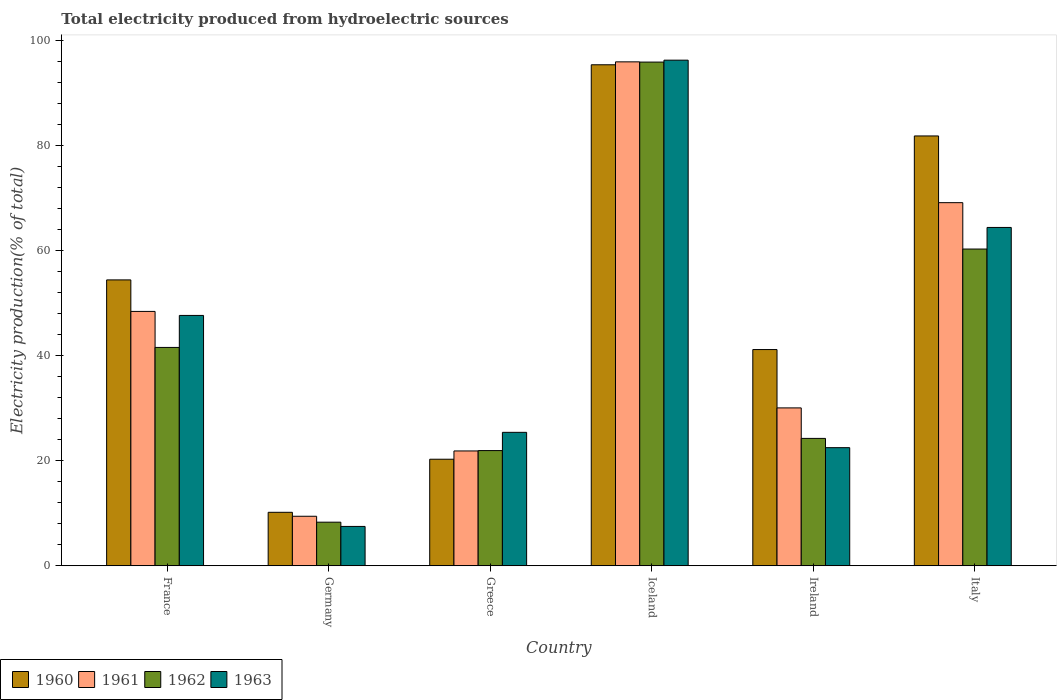How many different coloured bars are there?
Your response must be concise. 4. How many bars are there on the 2nd tick from the left?
Your answer should be compact. 4. How many bars are there on the 3rd tick from the right?
Offer a terse response. 4. What is the label of the 4th group of bars from the left?
Give a very brief answer. Iceland. In how many cases, is the number of bars for a given country not equal to the number of legend labels?
Your answer should be very brief. 0. What is the total electricity produced in 1963 in France?
Your answer should be compact. 47.7. Across all countries, what is the maximum total electricity produced in 1963?
Offer a very short reply. 96.34. Across all countries, what is the minimum total electricity produced in 1962?
Provide a short and direct response. 8.31. What is the total total electricity produced in 1963 in the graph?
Your answer should be compact. 263.95. What is the difference between the total electricity produced in 1963 in Iceland and that in Ireland?
Provide a succinct answer. 73.83. What is the difference between the total electricity produced in 1960 in Iceland and the total electricity produced in 1963 in Greece?
Keep it short and to the point. 70.03. What is the average total electricity produced in 1962 per country?
Your response must be concise. 42.08. What is the difference between the total electricity produced of/in 1963 and total electricity produced of/in 1961 in Ireland?
Provide a succinct answer. -7.58. What is the ratio of the total electricity produced in 1961 in Greece to that in Iceland?
Provide a short and direct response. 0.23. Is the total electricity produced in 1963 in Greece less than that in Iceland?
Provide a succinct answer. Yes. What is the difference between the highest and the second highest total electricity produced in 1960?
Give a very brief answer. 27.43. What is the difference between the highest and the lowest total electricity produced in 1962?
Your answer should be very brief. 87.67. In how many countries, is the total electricity produced in 1960 greater than the average total electricity produced in 1960 taken over all countries?
Make the answer very short. 3. Is it the case that in every country, the sum of the total electricity produced in 1963 and total electricity produced in 1960 is greater than the sum of total electricity produced in 1962 and total electricity produced in 1961?
Offer a terse response. No. What does the 3rd bar from the right in Germany represents?
Make the answer very short. 1961. Is it the case that in every country, the sum of the total electricity produced in 1960 and total electricity produced in 1963 is greater than the total electricity produced in 1961?
Your answer should be compact. Yes. How many bars are there?
Your response must be concise. 24. Are all the bars in the graph horizontal?
Make the answer very short. No. Are the values on the major ticks of Y-axis written in scientific E-notation?
Give a very brief answer. No. Does the graph contain any zero values?
Offer a very short reply. No. Does the graph contain grids?
Offer a very short reply. No. How many legend labels are there?
Provide a succinct answer. 4. How are the legend labels stacked?
Keep it short and to the point. Horizontal. What is the title of the graph?
Keep it short and to the point. Total electricity produced from hydroelectric sources. What is the label or title of the X-axis?
Make the answer very short. Country. What is the label or title of the Y-axis?
Ensure brevity in your answer.  Electricity production(% of total). What is the Electricity production(% of total) of 1960 in France?
Make the answer very short. 54.47. What is the Electricity production(% of total) in 1961 in France?
Offer a terse response. 48.47. What is the Electricity production(% of total) of 1962 in France?
Ensure brevity in your answer.  41.61. What is the Electricity production(% of total) of 1963 in France?
Offer a terse response. 47.7. What is the Electricity production(% of total) in 1960 in Germany?
Give a very brief answer. 10.19. What is the Electricity production(% of total) in 1961 in Germany?
Your response must be concise. 9.44. What is the Electricity production(% of total) in 1962 in Germany?
Provide a short and direct response. 8.31. What is the Electricity production(% of total) in 1963 in Germany?
Ensure brevity in your answer.  7.5. What is the Electricity production(% of total) in 1960 in Greece?
Your answer should be very brief. 20.31. What is the Electricity production(% of total) of 1961 in Greece?
Provide a succinct answer. 21.88. What is the Electricity production(% of total) of 1962 in Greece?
Ensure brevity in your answer.  21.95. What is the Electricity production(% of total) in 1963 in Greece?
Ensure brevity in your answer.  25.43. What is the Electricity production(% of total) in 1960 in Iceland?
Ensure brevity in your answer.  95.46. What is the Electricity production(% of total) of 1961 in Iceland?
Provide a short and direct response. 96.02. What is the Electricity production(% of total) in 1962 in Iceland?
Your response must be concise. 95.97. What is the Electricity production(% of total) of 1963 in Iceland?
Keep it short and to the point. 96.34. What is the Electricity production(% of total) in 1960 in Ireland?
Offer a very short reply. 41.2. What is the Electricity production(% of total) in 1961 in Ireland?
Ensure brevity in your answer.  30.09. What is the Electricity production(% of total) in 1962 in Ireland?
Keep it short and to the point. 24.27. What is the Electricity production(% of total) of 1963 in Ireland?
Your answer should be compact. 22.51. What is the Electricity production(% of total) in 1960 in Italy?
Your answer should be very brief. 81.9. What is the Electricity production(% of total) in 1961 in Italy?
Keep it short and to the point. 69.19. What is the Electricity production(% of total) in 1962 in Italy?
Offer a very short reply. 60.35. What is the Electricity production(% of total) of 1963 in Italy?
Your answer should be compact. 64.47. Across all countries, what is the maximum Electricity production(% of total) of 1960?
Provide a succinct answer. 95.46. Across all countries, what is the maximum Electricity production(% of total) in 1961?
Ensure brevity in your answer.  96.02. Across all countries, what is the maximum Electricity production(% of total) of 1962?
Give a very brief answer. 95.97. Across all countries, what is the maximum Electricity production(% of total) of 1963?
Make the answer very short. 96.34. Across all countries, what is the minimum Electricity production(% of total) in 1960?
Your answer should be compact. 10.19. Across all countries, what is the minimum Electricity production(% of total) of 1961?
Keep it short and to the point. 9.44. Across all countries, what is the minimum Electricity production(% of total) of 1962?
Your answer should be compact. 8.31. Across all countries, what is the minimum Electricity production(% of total) in 1963?
Your response must be concise. 7.5. What is the total Electricity production(% of total) of 1960 in the graph?
Provide a succinct answer. 303.54. What is the total Electricity production(% of total) in 1961 in the graph?
Make the answer very short. 275.08. What is the total Electricity production(% of total) in 1962 in the graph?
Provide a short and direct response. 252.47. What is the total Electricity production(% of total) of 1963 in the graph?
Offer a very short reply. 263.95. What is the difference between the Electricity production(% of total) in 1960 in France and that in Germany?
Make the answer very short. 44.28. What is the difference between the Electricity production(% of total) in 1961 in France and that in Germany?
Your answer should be compact. 39.03. What is the difference between the Electricity production(% of total) of 1962 in France and that in Germany?
Offer a terse response. 33.3. What is the difference between the Electricity production(% of total) in 1963 in France and that in Germany?
Ensure brevity in your answer.  40.2. What is the difference between the Electricity production(% of total) of 1960 in France and that in Greece?
Your answer should be very brief. 34.17. What is the difference between the Electricity production(% of total) in 1961 in France and that in Greece?
Ensure brevity in your answer.  26.58. What is the difference between the Electricity production(% of total) in 1962 in France and that in Greece?
Offer a very short reply. 19.66. What is the difference between the Electricity production(% of total) of 1963 in France and that in Greece?
Your answer should be compact. 22.27. What is the difference between the Electricity production(% of total) of 1960 in France and that in Iceland?
Your response must be concise. -40.99. What is the difference between the Electricity production(% of total) of 1961 in France and that in Iceland?
Ensure brevity in your answer.  -47.55. What is the difference between the Electricity production(% of total) of 1962 in France and that in Iceland?
Offer a very short reply. -54.37. What is the difference between the Electricity production(% of total) of 1963 in France and that in Iceland?
Offer a very short reply. -48.64. What is the difference between the Electricity production(% of total) of 1960 in France and that in Ireland?
Give a very brief answer. 13.27. What is the difference between the Electricity production(% of total) in 1961 in France and that in Ireland?
Offer a terse response. 18.38. What is the difference between the Electricity production(% of total) in 1962 in France and that in Ireland?
Your answer should be compact. 17.33. What is the difference between the Electricity production(% of total) of 1963 in France and that in Ireland?
Ensure brevity in your answer.  25.19. What is the difference between the Electricity production(% of total) of 1960 in France and that in Italy?
Your answer should be very brief. -27.43. What is the difference between the Electricity production(% of total) of 1961 in France and that in Italy?
Give a very brief answer. -20.72. What is the difference between the Electricity production(% of total) of 1962 in France and that in Italy?
Give a very brief answer. -18.75. What is the difference between the Electricity production(% of total) in 1963 in France and that in Italy?
Ensure brevity in your answer.  -16.77. What is the difference between the Electricity production(% of total) in 1960 in Germany and that in Greece?
Provide a short and direct response. -10.11. What is the difference between the Electricity production(% of total) in 1961 in Germany and that in Greece?
Offer a terse response. -12.45. What is the difference between the Electricity production(% of total) in 1962 in Germany and that in Greece?
Offer a terse response. -13.64. What is the difference between the Electricity production(% of total) in 1963 in Germany and that in Greece?
Offer a terse response. -17.93. What is the difference between the Electricity production(% of total) of 1960 in Germany and that in Iceland?
Give a very brief answer. -85.27. What is the difference between the Electricity production(% of total) in 1961 in Germany and that in Iceland?
Your answer should be very brief. -86.58. What is the difference between the Electricity production(% of total) in 1962 in Germany and that in Iceland?
Ensure brevity in your answer.  -87.67. What is the difference between the Electricity production(% of total) in 1963 in Germany and that in Iceland?
Your answer should be very brief. -88.84. What is the difference between the Electricity production(% of total) in 1960 in Germany and that in Ireland?
Your answer should be compact. -31.01. What is the difference between the Electricity production(% of total) of 1961 in Germany and that in Ireland?
Give a very brief answer. -20.65. What is the difference between the Electricity production(% of total) of 1962 in Germany and that in Ireland?
Offer a terse response. -15.96. What is the difference between the Electricity production(% of total) in 1963 in Germany and that in Ireland?
Ensure brevity in your answer.  -15.01. What is the difference between the Electricity production(% of total) of 1960 in Germany and that in Italy?
Your answer should be very brief. -71.71. What is the difference between the Electricity production(% of total) in 1961 in Germany and that in Italy?
Give a very brief answer. -59.75. What is the difference between the Electricity production(% of total) in 1962 in Germany and that in Italy?
Offer a very short reply. -52.05. What is the difference between the Electricity production(% of total) in 1963 in Germany and that in Italy?
Provide a short and direct response. -56.97. What is the difference between the Electricity production(% of total) in 1960 in Greece and that in Iceland?
Offer a terse response. -75.16. What is the difference between the Electricity production(% of total) in 1961 in Greece and that in Iceland?
Ensure brevity in your answer.  -74.14. What is the difference between the Electricity production(% of total) of 1962 in Greece and that in Iceland?
Your response must be concise. -74.02. What is the difference between the Electricity production(% of total) in 1963 in Greece and that in Iceland?
Keep it short and to the point. -70.91. What is the difference between the Electricity production(% of total) in 1960 in Greece and that in Ireland?
Give a very brief answer. -20.9. What is the difference between the Electricity production(% of total) of 1961 in Greece and that in Ireland?
Give a very brief answer. -8.2. What is the difference between the Electricity production(% of total) in 1962 in Greece and that in Ireland?
Provide a short and direct response. -2.32. What is the difference between the Electricity production(% of total) of 1963 in Greece and that in Ireland?
Your answer should be very brief. 2.92. What is the difference between the Electricity production(% of total) of 1960 in Greece and that in Italy?
Your answer should be compact. -61.59. What is the difference between the Electricity production(% of total) in 1961 in Greece and that in Italy?
Give a very brief answer. -47.31. What is the difference between the Electricity production(% of total) in 1962 in Greece and that in Italy?
Your response must be concise. -38.4. What is the difference between the Electricity production(% of total) in 1963 in Greece and that in Italy?
Provide a succinct answer. -39.04. What is the difference between the Electricity production(% of total) of 1960 in Iceland and that in Ireland?
Keep it short and to the point. 54.26. What is the difference between the Electricity production(% of total) of 1961 in Iceland and that in Ireland?
Give a very brief answer. 65.93. What is the difference between the Electricity production(% of total) in 1962 in Iceland and that in Ireland?
Keep it short and to the point. 71.7. What is the difference between the Electricity production(% of total) of 1963 in Iceland and that in Ireland?
Ensure brevity in your answer.  73.83. What is the difference between the Electricity production(% of total) in 1960 in Iceland and that in Italy?
Provide a short and direct response. 13.56. What is the difference between the Electricity production(% of total) of 1961 in Iceland and that in Italy?
Your answer should be very brief. 26.83. What is the difference between the Electricity production(% of total) of 1962 in Iceland and that in Italy?
Ensure brevity in your answer.  35.62. What is the difference between the Electricity production(% of total) of 1963 in Iceland and that in Italy?
Keep it short and to the point. 31.87. What is the difference between the Electricity production(% of total) in 1960 in Ireland and that in Italy?
Your answer should be compact. -40.7. What is the difference between the Electricity production(% of total) in 1961 in Ireland and that in Italy?
Your answer should be very brief. -39.1. What is the difference between the Electricity production(% of total) in 1962 in Ireland and that in Italy?
Your answer should be compact. -36.08. What is the difference between the Electricity production(% of total) in 1963 in Ireland and that in Italy?
Provide a short and direct response. -41.96. What is the difference between the Electricity production(% of total) in 1960 in France and the Electricity production(% of total) in 1961 in Germany?
Offer a very short reply. 45.04. What is the difference between the Electricity production(% of total) in 1960 in France and the Electricity production(% of total) in 1962 in Germany?
Offer a very short reply. 46.16. What is the difference between the Electricity production(% of total) of 1960 in France and the Electricity production(% of total) of 1963 in Germany?
Your answer should be compact. 46.97. What is the difference between the Electricity production(% of total) in 1961 in France and the Electricity production(% of total) in 1962 in Germany?
Provide a succinct answer. 40.16. What is the difference between the Electricity production(% of total) in 1961 in France and the Electricity production(% of total) in 1963 in Germany?
Ensure brevity in your answer.  40.97. What is the difference between the Electricity production(% of total) of 1962 in France and the Electricity production(% of total) of 1963 in Germany?
Your response must be concise. 34.11. What is the difference between the Electricity production(% of total) in 1960 in France and the Electricity production(% of total) in 1961 in Greece?
Provide a succinct answer. 32.59. What is the difference between the Electricity production(% of total) in 1960 in France and the Electricity production(% of total) in 1962 in Greece?
Make the answer very short. 32.52. What is the difference between the Electricity production(% of total) of 1960 in France and the Electricity production(% of total) of 1963 in Greece?
Make the answer very short. 29.05. What is the difference between the Electricity production(% of total) in 1961 in France and the Electricity production(% of total) in 1962 in Greece?
Give a very brief answer. 26.52. What is the difference between the Electricity production(% of total) in 1961 in France and the Electricity production(% of total) in 1963 in Greece?
Offer a terse response. 23.04. What is the difference between the Electricity production(% of total) of 1962 in France and the Electricity production(% of total) of 1963 in Greece?
Make the answer very short. 16.18. What is the difference between the Electricity production(% of total) in 1960 in France and the Electricity production(% of total) in 1961 in Iceland?
Give a very brief answer. -41.55. What is the difference between the Electricity production(% of total) in 1960 in France and the Electricity production(% of total) in 1962 in Iceland?
Offer a very short reply. -41.5. What is the difference between the Electricity production(% of total) in 1960 in France and the Electricity production(% of total) in 1963 in Iceland?
Offer a very short reply. -41.87. What is the difference between the Electricity production(% of total) of 1961 in France and the Electricity production(% of total) of 1962 in Iceland?
Provide a short and direct response. -47.51. What is the difference between the Electricity production(% of total) in 1961 in France and the Electricity production(% of total) in 1963 in Iceland?
Offer a terse response. -47.87. What is the difference between the Electricity production(% of total) in 1962 in France and the Electricity production(% of total) in 1963 in Iceland?
Provide a succinct answer. -54.74. What is the difference between the Electricity production(% of total) of 1960 in France and the Electricity production(% of total) of 1961 in Ireland?
Make the answer very short. 24.39. What is the difference between the Electricity production(% of total) in 1960 in France and the Electricity production(% of total) in 1962 in Ireland?
Give a very brief answer. 30.2. What is the difference between the Electricity production(% of total) of 1960 in France and the Electricity production(% of total) of 1963 in Ireland?
Ensure brevity in your answer.  31.96. What is the difference between the Electricity production(% of total) in 1961 in France and the Electricity production(% of total) in 1962 in Ireland?
Your answer should be compact. 24.2. What is the difference between the Electricity production(% of total) of 1961 in France and the Electricity production(% of total) of 1963 in Ireland?
Ensure brevity in your answer.  25.96. What is the difference between the Electricity production(% of total) of 1962 in France and the Electricity production(% of total) of 1963 in Ireland?
Ensure brevity in your answer.  19.1. What is the difference between the Electricity production(% of total) of 1960 in France and the Electricity production(% of total) of 1961 in Italy?
Provide a succinct answer. -14.72. What is the difference between the Electricity production(% of total) of 1960 in France and the Electricity production(% of total) of 1962 in Italy?
Offer a terse response. -5.88. What is the difference between the Electricity production(% of total) of 1960 in France and the Electricity production(% of total) of 1963 in Italy?
Make the answer very short. -9.99. What is the difference between the Electricity production(% of total) of 1961 in France and the Electricity production(% of total) of 1962 in Italy?
Provide a short and direct response. -11.89. What is the difference between the Electricity production(% of total) in 1961 in France and the Electricity production(% of total) in 1963 in Italy?
Your answer should be very brief. -16. What is the difference between the Electricity production(% of total) of 1962 in France and the Electricity production(% of total) of 1963 in Italy?
Your answer should be compact. -22.86. What is the difference between the Electricity production(% of total) of 1960 in Germany and the Electricity production(% of total) of 1961 in Greece?
Your answer should be very brief. -11.69. What is the difference between the Electricity production(% of total) in 1960 in Germany and the Electricity production(% of total) in 1962 in Greece?
Make the answer very short. -11.76. What is the difference between the Electricity production(% of total) in 1960 in Germany and the Electricity production(% of total) in 1963 in Greece?
Offer a terse response. -15.24. What is the difference between the Electricity production(% of total) in 1961 in Germany and the Electricity production(% of total) in 1962 in Greece?
Provide a short and direct response. -12.51. What is the difference between the Electricity production(% of total) in 1961 in Germany and the Electricity production(% of total) in 1963 in Greece?
Make the answer very short. -15.99. What is the difference between the Electricity production(% of total) in 1962 in Germany and the Electricity production(% of total) in 1963 in Greece?
Give a very brief answer. -17.12. What is the difference between the Electricity production(% of total) of 1960 in Germany and the Electricity production(% of total) of 1961 in Iceland?
Give a very brief answer. -85.83. What is the difference between the Electricity production(% of total) in 1960 in Germany and the Electricity production(% of total) in 1962 in Iceland?
Your response must be concise. -85.78. What is the difference between the Electricity production(% of total) of 1960 in Germany and the Electricity production(% of total) of 1963 in Iceland?
Your response must be concise. -86.15. What is the difference between the Electricity production(% of total) of 1961 in Germany and the Electricity production(% of total) of 1962 in Iceland?
Your response must be concise. -86.54. What is the difference between the Electricity production(% of total) of 1961 in Germany and the Electricity production(% of total) of 1963 in Iceland?
Offer a very short reply. -86.9. What is the difference between the Electricity production(% of total) in 1962 in Germany and the Electricity production(% of total) in 1963 in Iceland?
Offer a terse response. -88.03. What is the difference between the Electricity production(% of total) of 1960 in Germany and the Electricity production(% of total) of 1961 in Ireland?
Offer a terse response. -19.89. What is the difference between the Electricity production(% of total) in 1960 in Germany and the Electricity production(% of total) in 1962 in Ireland?
Provide a short and direct response. -14.08. What is the difference between the Electricity production(% of total) in 1960 in Germany and the Electricity production(% of total) in 1963 in Ireland?
Ensure brevity in your answer.  -12.32. What is the difference between the Electricity production(% of total) in 1961 in Germany and the Electricity production(% of total) in 1962 in Ireland?
Your answer should be compact. -14.84. What is the difference between the Electricity production(% of total) in 1961 in Germany and the Electricity production(% of total) in 1963 in Ireland?
Your answer should be compact. -13.07. What is the difference between the Electricity production(% of total) in 1962 in Germany and the Electricity production(% of total) in 1963 in Ireland?
Ensure brevity in your answer.  -14.2. What is the difference between the Electricity production(% of total) of 1960 in Germany and the Electricity production(% of total) of 1961 in Italy?
Provide a succinct answer. -59. What is the difference between the Electricity production(% of total) in 1960 in Germany and the Electricity production(% of total) in 1962 in Italy?
Your answer should be very brief. -50.16. What is the difference between the Electricity production(% of total) of 1960 in Germany and the Electricity production(% of total) of 1963 in Italy?
Your answer should be compact. -54.28. What is the difference between the Electricity production(% of total) in 1961 in Germany and the Electricity production(% of total) in 1962 in Italy?
Your response must be concise. -50.92. What is the difference between the Electricity production(% of total) in 1961 in Germany and the Electricity production(% of total) in 1963 in Italy?
Ensure brevity in your answer.  -55.03. What is the difference between the Electricity production(% of total) of 1962 in Germany and the Electricity production(% of total) of 1963 in Italy?
Ensure brevity in your answer.  -56.16. What is the difference between the Electricity production(% of total) of 1960 in Greece and the Electricity production(% of total) of 1961 in Iceland?
Make the answer very short. -75.71. What is the difference between the Electricity production(% of total) of 1960 in Greece and the Electricity production(% of total) of 1962 in Iceland?
Your answer should be very brief. -75.67. What is the difference between the Electricity production(% of total) of 1960 in Greece and the Electricity production(% of total) of 1963 in Iceland?
Offer a very short reply. -76.04. What is the difference between the Electricity production(% of total) in 1961 in Greece and the Electricity production(% of total) in 1962 in Iceland?
Provide a succinct answer. -74.09. What is the difference between the Electricity production(% of total) of 1961 in Greece and the Electricity production(% of total) of 1963 in Iceland?
Offer a terse response. -74.46. What is the difference between the Electricity production(% of total) of 1962 in Greece and the Electricity production(% of total) of 1963 in Iceland?
Offer a very short reply. -74.39. What is the difference between the Electricity production(% of total) of 1960 in Greece and the Electricity production(% of total) of 1961 in Ireland?
Your answer should be compact. -9.78. What is the difference between the Electricity production(% of total) of 1960 in Greece and the Electricity production(% of total) of 1962 in Ireland?
Offer a very short reply. -3.97. What is the difference between the Electricity production(% of total) in 1960 in Greece and the Electricity production(% of total) in 1963 in Ireland?
Make the answer very short. -2.2. What is the difference between the Electricity production(% of total) of 1961 in Greece and the Electricity production(% of total) of 1962 in Ireland?
Your answer should be compact. -2.39. What is the difference between the Electricity production(% of total) of 1961 in Greece and the Electricity production(% of total) of 1963 in Ireland?
Provide a short and direct response. -0.63. What is the difference between the Electricity production(% of total) of 1962 in Greece and the Electricity production(% of total) of 1963 in Ireland?
Offer a terse response. -0.56. What is the difference between the Electricity production(% of total) in 1960 in Greece and the Electricity production(% of total) in 1961 in Italy?
Your answer should be very brief. -48.88. What is the difference between the Electricity production(% of total) in 1960 in Greece and the Electricity production(% of total) in 1962 in Italy?
Your response must be concise. -40.05. What is the difference between the Electricity production(% of total) in 1960 in Greece and the Electricity production(% of total) in 1963 in Italy?
Offer a terse response. -44.16. What is the difference between the Electricity production(% of total) in 1961 in Greece and the Electricity production(% of total) in 1962 in Italy?
Ensure brevity in your answer.  -38.47. What is the difference between the Electricity production(% of total) in 1961 in Greece and the Electricity production(% of total) in 1963 in Italy?
Keep it short and to the point. -42.58. What is the difference between the Electricity production(% of total) of 1962 in Greece and the Electricity production(% of total) of 1963 in Italy?
Your answer should be very brief. -42.52. What is the difference between the Electricity production(% of total) in 1960 in Iceland and the Electricity production(% of total) in 1961 in Ireland?
Offer a very short reply. 65.38. What is the difference between the Electricity production(% of total) of 1960 in Iceland and the Electricity production(% of total) of 1962 in Ireland?
Give a very brief answer. 71.19. What is the difference between the Electricity production(% of total) of 1960 in Iceland and the Electricity production(% of total) of 1963 in Ireland?
Your response must be concise. 72.95. What is the difference between the Electricity production(% of total) of 1961 in Iceland and the Electricity production(% of total) of 1962 in Ireland?
Offer a very short reply. 71.75. What is the difference between the Electricity production(% of total) in 1961 in Iceland and the Electricity production(% of total) in 1963 in Ireland?
Your answer should be compact. 73.51. What is the difference between the Electricity production(% of total) in 1962 in Iceland and the Electricity production(% of total) in 1963 in Ireland?
Keep it short and to the point. 73.47. What is the difference between the Electricity production(% of total) in 1960 in Iceland and the Electricity production(% of total) in 1961 in Italy?
Offer a very short reply. 26.27. What is the difference between the Electricity production(% of total) in 1960 in Iceland and the Electricity production(% of total) in 1962 in Italy?
Offer a very short reply. 35.11. What is the difference between the Electricity production(% of total) in 1960 in Iceland and the Electricity production(% of total) in 1963 in Italy?
Keep it short and to the point. 30.99. What is the difference between the Electricity production(% of total) in 1961 in Iceland and the Electricity production(% of total) in 1962 in Italy?
Your response must be concise. 35.67. What is the difference between the Electricity production(% of total) of 1961 in Iceland and the Electricity production(% of total) of 1963 in Italy?
Your response must be concise. 31.55. What is the difference between the Electricity production(% of total) in 1962 in Iceland and the Electricity production(% of total) in 1963 in Italy?
Your answer should be compact. 31.51. What is the difference between the Electricity production(% of total) of 1960 in Ireland and the Electricity production(% of total) of 1961 in Italy?
Ensure brevity in your answer.  -27.99. What is the difference between the Electricity production(% of total) of 1960 in Ireland and the Electricity production(% of total) of 1962 in Italy?
Make the answer very short. -19.15. What is the difference between the Electricity production(% of total) in 1960 in Ireland and the Electricity production(% of total) in 1963 in Italy?
Give a very brief answer. -23.27. What is the difference between the Electricity production(% of total) in 1961 in Ireland and the Electricity production(% of total) in 1962 in Italy?
Your response must be concise. -30.27. What is the difference between the Electricity production(% of total) of 1961 in Ireland and the Electricity production(% of total) of 1963 in Italy?
Your answer should be compact. -34.38. What is the difference between the Electricity production(% of total) in 1962 in Ireland and the Electricity production(% of total) in 1963 in Italy?
Keep it short and to the point. -40.2. What is the average Electricity production(% of total) in 1960 per country?
Offer a very short reply. 50.59. What is the average Electricity production(% of total) in 1961 per country?
Provide a succinct answer. 45.85. What is the average Electricity production(% of total) in 1962 per country?
Offer a terse response. 42.08. What is the average Electricity production(% of total) of 1963 per country?
Your answer should be compact. 43.99. What is the difference between the Electricity production(% of total) of 1960 and Electricity production(% of total) of 1961 in France?
Give a very brief answer. 6.01. What is the difference between the Electricity production(% of total) of 1960 and Electricity production(% of total) of 1962 in France?
Make the answer very short. 12.87. What is the difference between the Electricity production(% of total) in 1960 and Electricity production(% of total) in 1963 in France?
Your answer should be very brief. 6.77. What is the difference between the Electricity production(% of total) in 1961 and Electricity production(% of total) in 1962 in France?
Provide a short and direct response. 6.86. What is the difference between the Electricity production(% of total) in 1961 and Electricity production(% of total) in 1963 in France?
Keep it short and to the point. 0.77. What is the difference between the Electricity production(% of total) of 1962 and Electricity production(% of total) of 1963 in France?
Give a very brief answer. -6.1. What is the difference between the Electricity production(% of total) of 1960 and Electricity production(% of total) of 1961 in Germany?
Offer a very short reply. 0.76. What is the difference between the Electricity production(% of total) in 1960 and Electricity production(% of total) in 1962 in Germany?
Offer a very short reply. 1.88. What is the difference between the Electricity production(% of total) in 1960 and Electricity production(% of total) in 1963 in Germany?
Provide a short and direct response. 2.69. What is the difference between the Electricity production(% of total) in 1961 and Electricity production(% of total) in 1962 in Germany?
Offer a very short reply. 1.13. What is the difference between the Electricity production(% of total) of 1961 and Electricity production(% of total) of 1963 in Germany?
Your answer should be very brief. 1.94. What is the difference between the Electricity production(% of total) of 1962 and Electricity production(% of total) of 1963 in Germany?
Offer a terse response. 0.81. What is the difference between the Electricity production(% of total) in 1960 and Electricity production(% of total) in 1961 in Greece?
Make the answer very short. -1.58. What is the difference between the Electricity production(% of total) in 1960 and Electricity production(% of total) in 1962 in Greece?
Provide a short and direct response. -1.64. What is the difference between the Electricity production(% of total) in 1960 and Electricity production(% of total) in 1963 in Greece?
Your answer should be very brief. -5.12. What is the difference between the Electricity production(% of total) of 1961 and Electricity production(% of total) of 1962 in Greece?
Offer a very short reply. -0.07. What is the difference between the Electricity production(% of total) of 1961 and Electricity production(% of total) of 1963 in Greece?
Offer a very short reply. -3.54. What is the difference between the Electricity production(% of total) in 1962 and Electricity production(% of total) in 1963 in Greece?
Offer a terse response. -3.48. What is the difference between the Electricity production(% of total) in 1960 and Electricity production(% of total) in 1961 in Iceland?
Your answer should be compact. -0.56. What is the difference between the Electricity production(% of total) in 1960 and Electricity production(% of total) in 1962 in Iceland?
Make the answer very short. -0.51. What is the difference between the Electricity production(% of total) of 1960 and Electricity production(% of total) of 1963 in Iceland?
Give a very brief answer. -0.88. What is the difference between the Electricity production(% of total) of 1961 and Electricity production(% of total) of 1962 in Iceland?
Ensure brevity in your answer.  0.05. What is the difference between the Electricity production(% of total) in 1961 and Electricity production(% of total) in 1963 in Iceland?
Offer a very short reply. -0.32. What is the difference between the Electricity production(% of total) in 1962 and Electricity production(% of total) in 1963 in Iceland?
Offer a terse response. -0.37. What is the difference between the Electricity production(% of total) of 1960 and Electricity production(% of total) of 1961 in Ireland?
Give a very brief answer. 11.12. What is the difference between the Electricity production(% of total) in 1960 and Electricity production(% of total) in 1962 in Ireland?
Keep it short and to the point. 16.93. What is the difference between the Electricity production(% of total) in 1960 and Electricity production(% of total) in 1963 in Ireland?
Ensure brevity in your answer.  18.69. What is the difference between the Electricity production(% of total) in 1961 and Electricity production(% of total) in 1962 in Ireland?
Make the answer very short. 5.81. What is the difference between the Electricity production(% of total) of 1961 and Electricity production(% of total) of 1963 in Ireland?
Make the answer very short. 7.58. What is the difference between the Electricity production(% of total) in 1962 and Electricity production(% of total) in 1963 in Ireland?
Keep it short and to the point. 1.76. What is the difference between the Electricity production(% of total) of 1960 and Electricity production(% of total) of 1961 in Italy?
Your answer should be compact. 12.71. What is the difference between the Electricity production(% of total) of 1960 and Electricity production(% of total) of 1962 in Italy?
Your answer should be compact. 21.55. What is the difference between the Electricity production(% of total) of 1960 and Electricity production(% of total) of 1963 in Italy?
Keep it short and to the point. 17.43. What is the difference between the Electricity production(% of total) in 1961 and Electricity production(% of total) in 1962 in Italy?
Ensure brevity in your answer.  8.84. What is the difference between the Electricity production(% of total) in 1961 and Electricity production(% of total) in 1963 in Italy?
Provide a short and direct response. 4.72. What is the difference between the Electricity production(% of total) of 1962 and Electricity production(% of total) of 1963 in Italy?
Provide a short and direct response. -4.11. What is the ratio of the Electricity production(% of total) of 1960 in France to that in Germany?
Offer a terse response. 5.34. What is the ratio of the Electricity production(% of total) of 1961 in France to that in Germany?
Offer a very short reply. 5.14. What is the ratio of the Electricity production(% of total) of 1962 in France to that in Germany?
Ensure brevity in your answer.  5.01. What is the ratio of the Electricity production(% of total) in 1963 in France to that in Germany?
Offer a terse response. 6.36. What is the ratio of the Electricity production(% of total) of 1960 in France to that in Greece?
Your answer should be compact. 2.68. What is the ratio of the Electricity production(% of total) of 1961 in France to that in Greece?
Provide a short and direct response. 2.21. What is the ratio of the Electricity production(% of total) of 1962 in France to that in Greece?
Make the answer very short. 1.9. What is the ratio of the Electricity production(% of total) in 1963 in France to that in Greece?
Keep it short and to the point. 1.88. What is the ratio of the Electricity production(% of total) of 1960 in France to that in Iceland?
Your answer should be compact. 0.57. What is the ratio of the Electricity production(% of total) of 1961 in France to that in Iceland?
Make the answer very short. 0.5. What is the ratio of the Electricity production(% of total) of 1962 in France to that in Iceland?
Give a very brief answer. 0.43. What is the ratio of the Electricity production(% of total) in 1963 in France to that in Iceland?
Provide a succinct answer. 0.5. What is the ratio of the Electricity production(% of total) in 1960 in France to that in Ireland?
Offer a terse response. 1.32. What is the ratio of the Electricity production(% of total) in 1961 in France to that in Ireland?
Your response must be concise. 1.61. What is the ratio of the Electricity production(% of total) in 1962 in France to that in Ireland?
Ensure brevity in your answer.  1.71. What is the ratio of the Electricity production(% of total) in 1963 in France to that in Ireland?
Keep it short and to the point. 2.12. What is the ratio of the Electricity production(% of total) of 1960 in France to that in Italy?
Your response must be concise. 0.67. What is the ratio of the Electricity production(% of total) in 1961 in France to that in Italy?
Provide a succinct answer. 0.7. What is the ratio of the Electricity production(% of total) of 1962 in France to that in Italy?
Offer a very short reply. 0.69. What is the ratio of the Electricity production(% of total) of 1963 in France to that in Italy?
Offer a terse response. 0.74. What is the ratio of the Electricity production(% of total) in 1960 in Germany to that in Greece?
Give a very brief answer. 0.5. What is the ratio of the Electricity production(% of total) of 1961 in Germany to that in Greece?
Provide a succinct answer. 0.43. What is the ratio of the Electricity production(% of total) of 1962 in Germany to that in Greece?
Offer a terse response. 0.38. What is the ratio of the Electricity production(% of total) in 1963 in Germany to that in Greece?
Give a very brief answer. 0.29. What is the ratio of the Electricity production(% of total) in 1960 in Germany to that in Iceland?
Your response must be concise. 0.11. What is the ratio of the Electricity production(% of total) in 1961 in Germany to that in Iceland?
Offer a very short reply. 0.1. What is the ratio of the Electricity production(% of total) in 1962 in Germany to that in Iceland?
Keep it short and to the point. 0.09. What is the ratio of the Electricity production(% of total) of 1963 in Germany to that in Iceland?
Give a very brief answer. 0.08. What is the ratio of the Electricity production(% of total) of 1960 in Germany to that in Ireland?
Make the answer very short. 0.25. What is the ratio of the Electricity production(% of total) of 1961 in Germany to that in Ireland?
Provide a short and direct response. 0.31. What is the ratio of the Electricity production(% of total) of 1962 in Germany to that in Ireland?
Keep it short and to the point. 0.34. What is the ratio of the Electricity production(% of total) in 1963 in Germany to that in Ireland?
Keep it short and to the point. 0.33. What is the ratio of the Electricity production(% of total) in 1960 in Germany to that in Italy?
Ensure brevity in your answer.  0.12. What is the ratio of the Electricity production(% of total) of 1961 in Germany to that in Italy?
Ensure brevity in your answer.  0.14. What is the ratio of the Electricity production(% of total) in 1962 in Germany to that in Italy?
Give a very brief answer. 0.14. What is the ratio of the Electricity production(% of total) of 1963 in Germany to that in Italy?
Your answer should be compact. 0.12. What is the ratio of the Electricity production(% of total) of 1960 in Greece to that in Iceland?
Your response must be concise. 0.21. What is the ratio of the Electricity production(% of total) in 1961 in Greece to that in Iceland?
Offer a terse response. 0.23. What is the ratio of the Electricity production(% of total) of 1962 in Greece to that in Iceland?
Ensure brevity in your answer.  0.23. What is the ratio of the Electricity production(% of total) of 1963 in Greece to that in Iceland?
Keep it short and to the point. 0.26. What is the ratio of the Electricity production(% of total) in 1960 in Greece to that in Ireland?
Provide a succinct answer. 0.49. What is the ratio of the Electricity production(% of total) of 1961 in Greece to that in Ireland?
Make the answer very short. 0.73. What is the ratio of the Electricity production(% of total) of 1962 in Greece to that in Ireland?
Provide a short and direct response. 0.9. What is the ratio of the Electricity production(% of total) in 1963 in Greece to that in Ireland?
Ensure brevity in your answer.  1.13. What is the ratio of the Electricity production(% of total) in 1960 in Greece to that in Italy?
Ensure brevity in your answer.  0.25. What is the ratio of the Electricity production(% of total) in 1961 in Greece to that in Italy?
Your response must be concise. 0.32. What is the ratio of the Electricity production(% of total) of 1962 in Greece to that in Italy?
Keep it short and to the point. 0.36. What is the ratio of the Electricity production(% of total) of 1963 in Greece to that in Italy?
Ensure brevity in your answer.  0.39. What is the ratio of the Electricity production(% of total) of 1960 in Iceland to that in Ireland?
Offer a very short reply. 2.32. What is the ratio of the Electricity production(% of total) of 1961 in Iceland to that in Ireland?
Your answer should be very brief. 3.19. What is the ratio of the Electricity production(% of total) of 1962 in Iceland to that in Ireland?
Provide a succinct answer. 3.95. What is the ratio of the Electricity production(% of total) in 1963 in Iceland to that in Ireland?
Your answer should be compact. 4.28. What is the ratio of the Electricity production(% of total) of 1960 in Iceland to that in Italy?
Give a very brief answer. 1.17. What is the ratio of the Electricity production(% of total) in 1961 in Iceland to that in Italy?
Provide a succinct answer. 1.39. What is the ratio of the Electricity production(% of total) of 1962 in Iceland to that in Italy?
Provide a short and direct response. 1.59. What is the ratio of the Electricity production(% of total) of 1963 in Iceland to that in Italy?
Your answer should be compact. 1.49. What is the ratio of the Electricity production(% of total) in 1960 in Ireland to that in Italy?
Provide a short and direct response. 0.5. What is the ratio of the Electricity production(% of total) of 1961 in Ireland to that in Italy?
Offer a terse response. 0.43. What is the ratio of the Electricity production(% of total) in 1962 in Ireland to that in Italy?
Provide a short and direct response. 0.4. What is the ratio of the Electricity production(% of total) in 1963 in Ireland to that in Italy?
Your answer should be very brief. 0.35. What is the difference between the highest and the second highest Electricity production(% of total) in 1960?
Ensure brevity in your answer.  13.56. What is the difference between the highest and the second highest Electricity production(% of total) of 1961?
Provide a succinct answer. 26.83. What is the difference between the highest and the second highest Electricity production(% of total) in 1962?
Give a very brief answer. 35.62. What is the difference between the highest and the second highest Electricity production(% of total) in 1963?
Give a very brief answer. 31.87. What is the difference between the highest and the lowest Electricity production(% of total) of 1960?
Provide a short and direct response. 85.27. What is the difference between the highest and the lowest Electricity production(% of total) of 1961?
Offer a terse response. 86.58. What is the difference between the highest and the lowest Electricity production(% of total) in 1962?
Provide a short and direct response. 87.67. What is the difference between the highest and the lowest Electricity production(% of total) in 1963?
Ensure brevity in your answer.  88.84. 